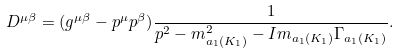<formula> <loc_0><loc_0><loc_500><loc_500>D ^ { \mu \beta } = ( g ^ { \mu \beta } - p ^ { \mu } p ^ { \beta } ) \frac { 1 } { p ^ { 2 } - m _ { a _ { 1 } ( K _ { 1 } ) } ^ { 2 } - I m _ { a _ { 1 } ( K _ { 1 } ) } \Gamma _ { a _ { 1 } ( K _ { 1 } ) } } .</formula> 